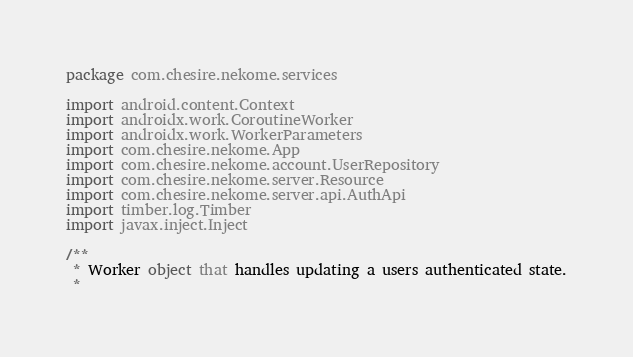Convert code to text. <code><loc_0><loc_0><loc_500><loc_500><_Kotlin_>package com.chesire.nekome.services

import android.content.Context
import androidx.work.CoroutineWorker
import androidx.work.WorkerParameters
import com.chesire.nekome.App
import com.chesire.nekome.account.UserRepository
import com.chesire.nekome.server.Resource
import com.chesire.nekome.server.api.AuthApi
import timber.log.Timber
import javax.inject.Inject

/**
 * Worker object that handles updating a users authenticated state.
 *</code> 